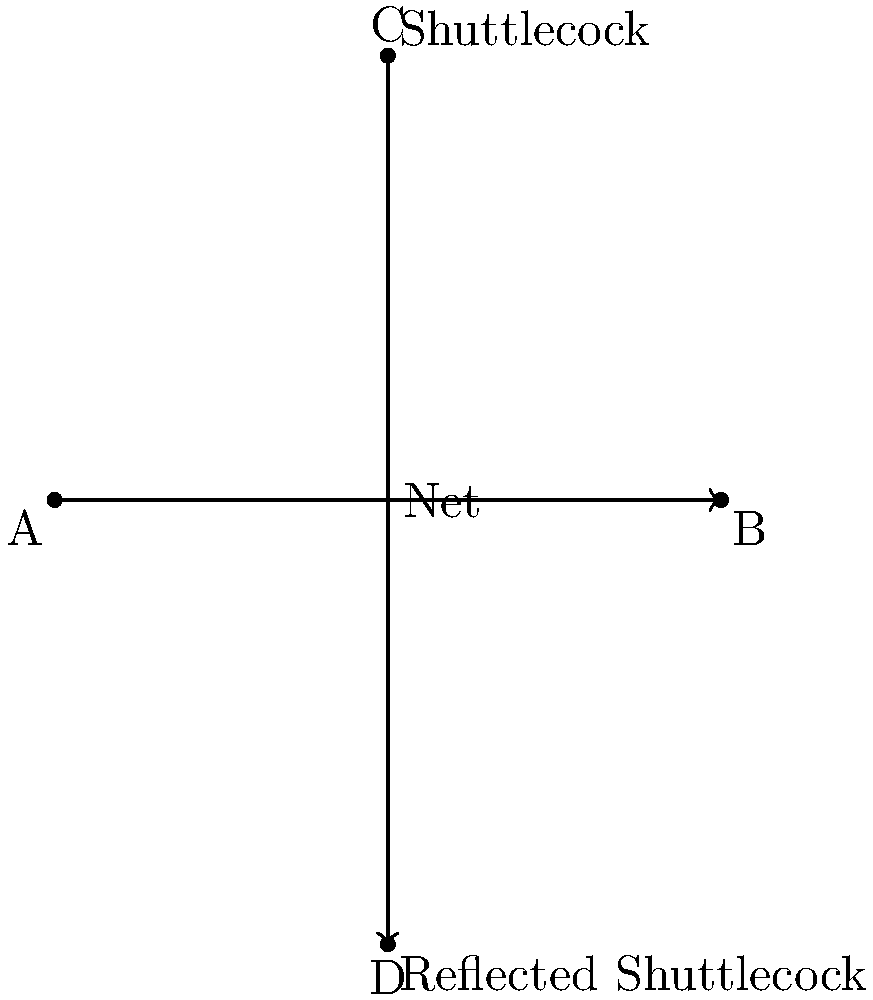In a badminton court, a shuttlecock is at point C(3,4) above the net. If the net is represented by the x-axis, and the shuttlecock is reflected across the net, what are the coordinates of the reflected shuttlecock's position? To solve this problem, we need to use the concept of reflection across a line in transformational geometry. Here's a step-by-step explanation:

1) The net is represented by the x-axis, which means it's the line y = 0.

2) The original shuttlecock position is at point C(3,4).

3) When reflecting a point across the x-axis, the x-coordinate remains the same, but the y-coordinate changes sign.

4) Therefore, to find the reflected position:
   - The x-coordinate will still be 3
   - The y-coordinate will change from 4 to -4

5) So, the coordinates of the reflected shuttlecock will be (3,-4).

This reflection can be represented mathematically as:
$$(x,y) \rightarrow (x,-y)$$

In this case:
$$(3,4) \rightarrow (3,-4)$$
Answer: (3,-4) 